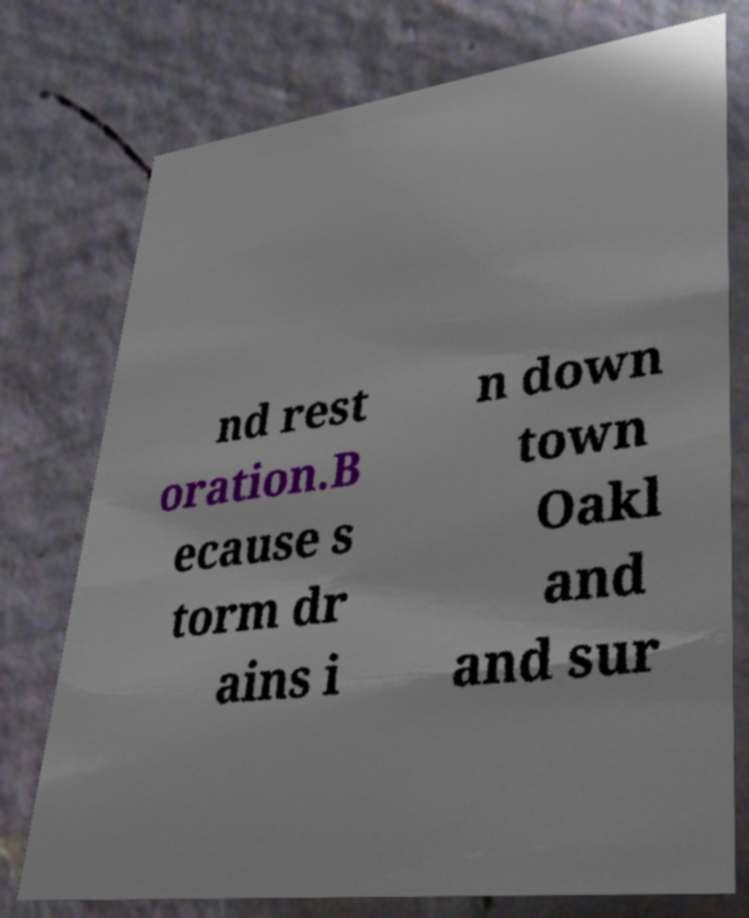Can you accurately transcribe the text from the provided image for me? nd rest oration.B ecause s torm dr ains i n down town Oakl and and sur 